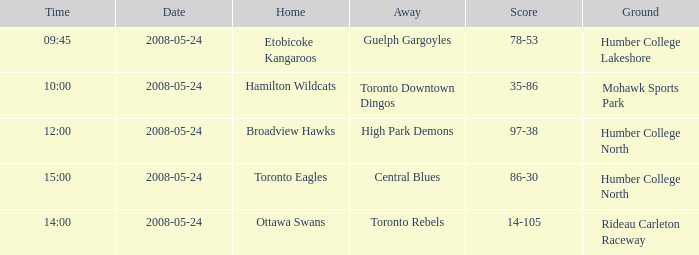On what day was the game that ended in a score of 97-38? 2008-05-24. 